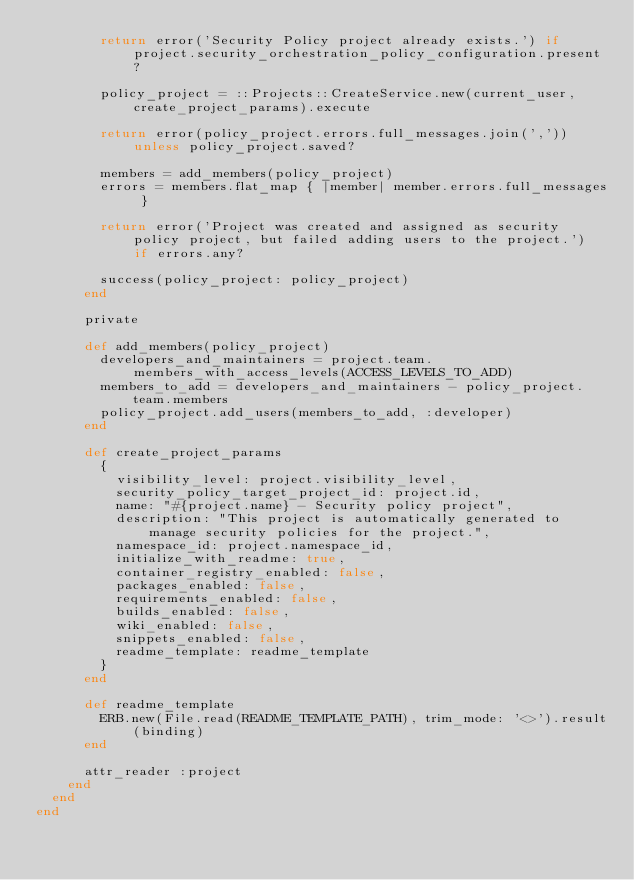<code> <loc_0><loc_0><loc_500><loc_500><_Ruby_>        return error('Security Policy project already exists.') if project.security_orchestration_policy_configuration.present?

        policy_project = ::Projects::CreateService.new(current_user, create_project_params).execute

        return error(policy_project.errors.full_messages.join(',')) unless policy_project.saved?

        members = add_members(policy_project)
        errors = members.flat_map { |member| member.errors.full_messages }

        return error('Project was created and assigned as security policy project, but failed adding users to the project.') if errors.any?

        success(policy_project: policy_project)
      end

      private

      def add_members(policy_project)
        developers_and_maintainers = project.team.members_with_access_levels(ACCESS_LEVELS_TO_ADD)
        members_to_add = developers_and_maintainers - policy_project.team.members
        policy_project.add_users(members_to_add, :developer)
      end

      def create_project_params
        {
          visibility_level: project.visibility_level,
          security_policy_target_project_id: project.id,
          name: "#{project.name} - Security policy project",
          description: "This project is automatically generated to manage security policies for the project.",
          namespace_id: project.namespace_id,
          initialize_with_readme: true,
          container_registry_enabled: false,
          packages_enabled: false,
          requirements_enabled: false,
          builds_enabled: false,
          wiki_enabled: false,
          snippets_enabled: false,
          readme_template: readme_template
        }
      end

      def readme_template
        ERB.new(File.read(README_TEMPLATE_PATH), trim_mode: '<>').result(binding)
      end

      attr_reader :project
    end
  end
end
</code> 